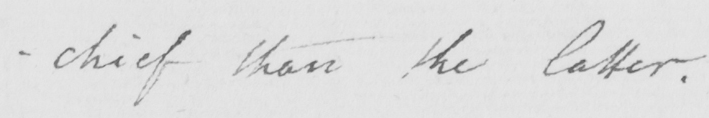What text is written in this handwritten line? -chief than the latter . 